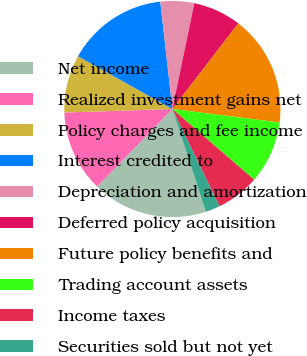Convert chart. <chart><loc_0><loc_0><loc_500><loc_500><pie_chart><fcel>Net income<fcel>Realized investment gains net<fcel>Policy charges and fee income<fcel>Interest credited to<fcel>Depreciation and amortization<fcel>Deferred policy acquisition<fcel>Future policy benefits and<fcel>Trading account assets<fcel>Income taxes<fcel>Securities sold but not yet<nl><fcel>17.27%<fcel>12.23%<fcel>8.63%<fcel>15.11%<fcel>5.04%<fcel>7.19%<fcel>16.55%<fcel>9.35%<fcel>6.48%<fcel>2.16%<nl></chart> 